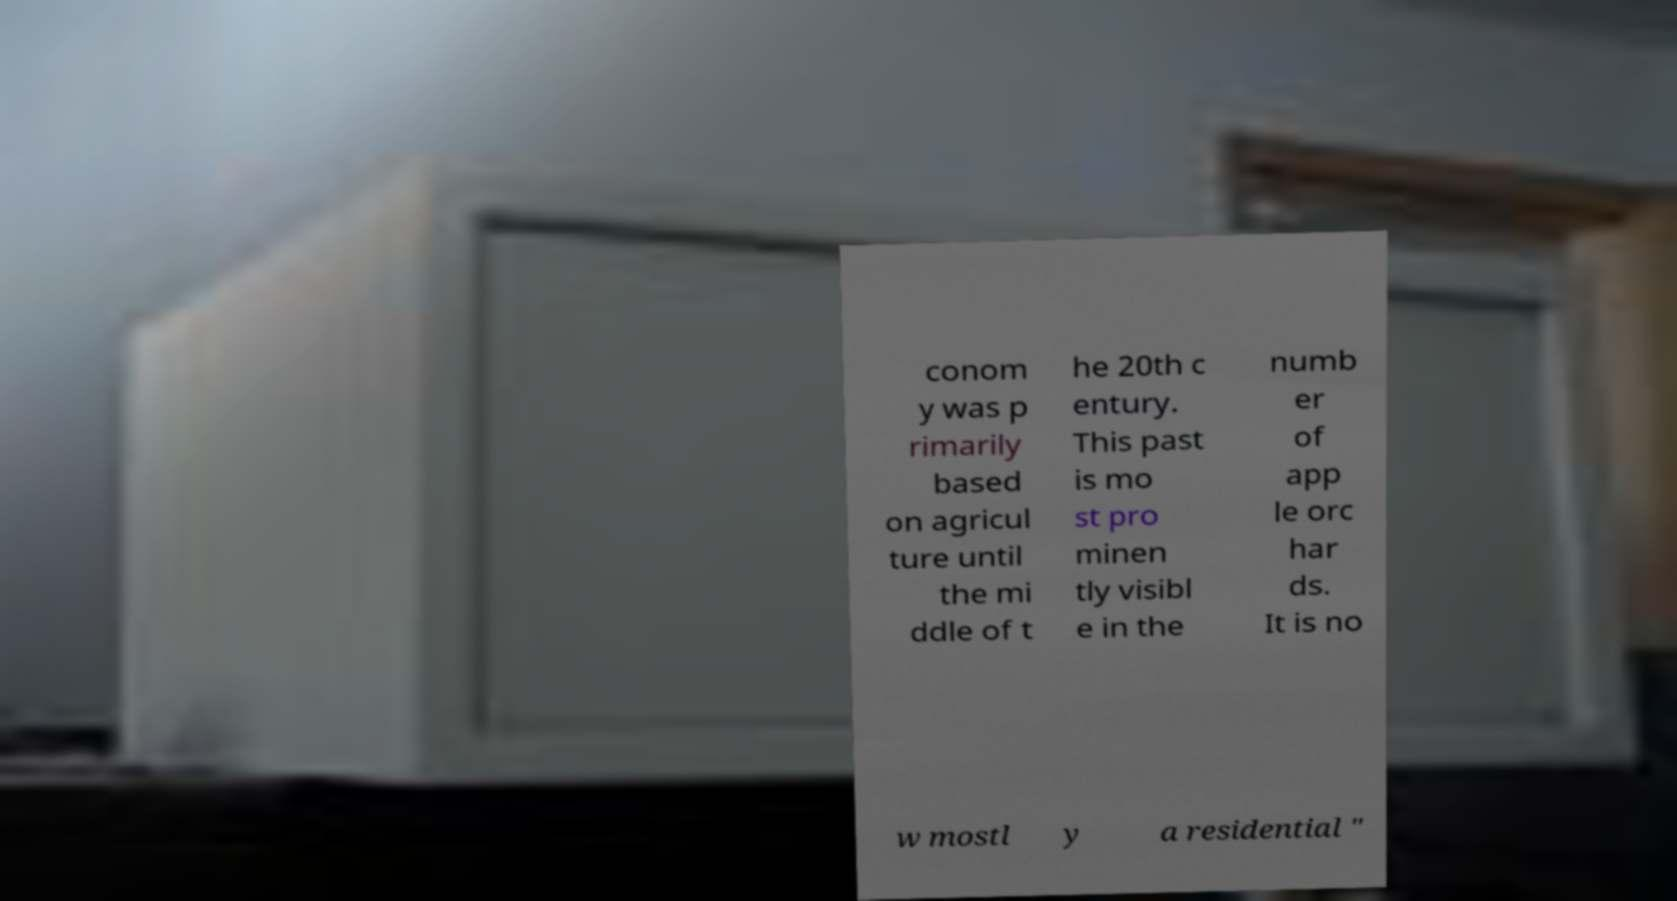Please read and relay the text visible in this image. What does it say? conom y was p rimarily based on agricul ture until the mi ddle of t he 20th c entury. This past is mo st pro minen tly visibl e in the numb er of app le orc har ds. It is no w mostl y a residential " 